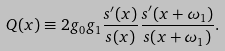Convert formula to latex. <formula><loc_0><loc_0><loc_500><loc_500>Q ( x ) \equiv 2 g _ { 0 } g _ { 1 } \frac { s ^ { \prime } ( x ) } { s ( x ) } \frac { s ^ { \prime } ( x + \omega _ { 1 } ) } { s ( x + \omega _ { 1 } ) } .</formula> 